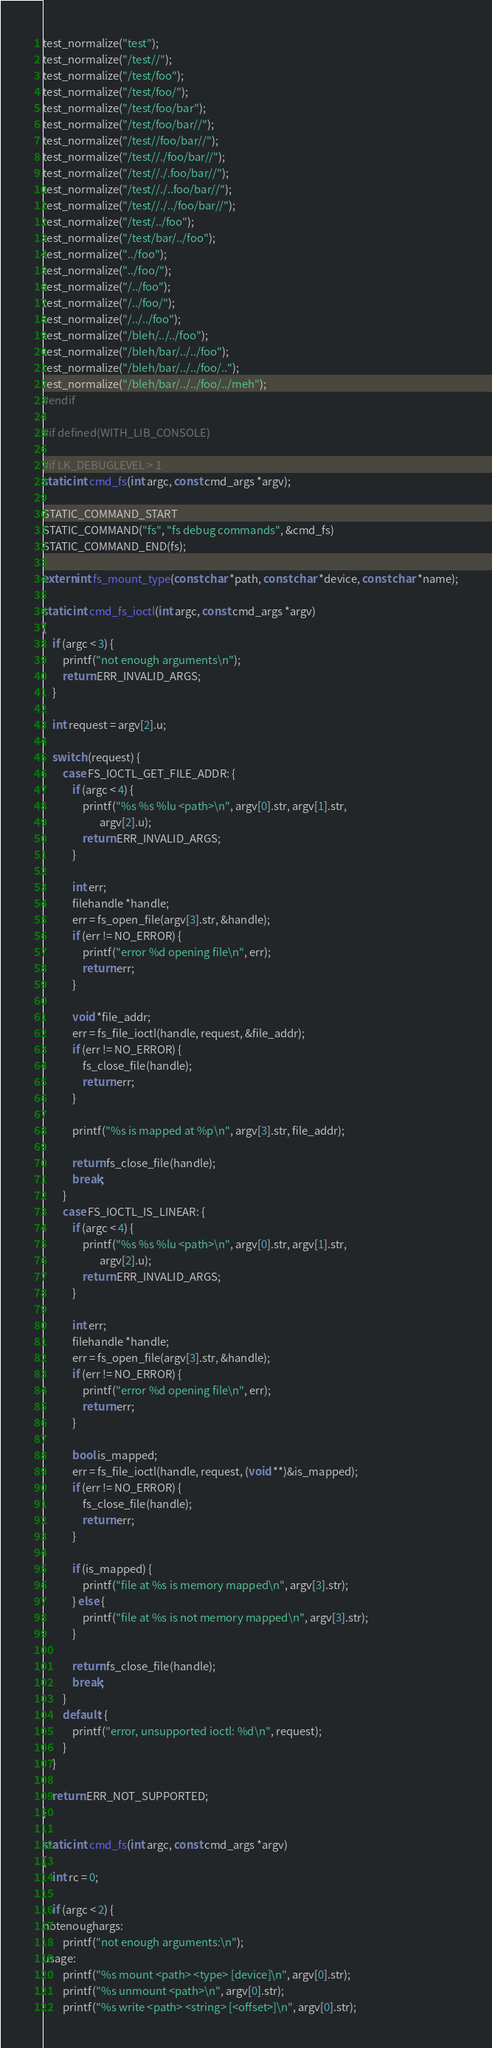<code> <loc_0><loc_0><loc_500><loc_500><_C_>test_normalize("test");
test_normalize("/test//");
test_normalize("/test/foo");
test_normalize("/test/foo/");
test_normalize("/test/foo/bar");
test_normalize("/test/foo/bar//");
test_normalize("/test//foo/bar//");
test_normalize("/test//./foo/bar//");
test_normalize("/test//./.foo/bar//");
test_normalize("/test//./..foo/bar//");
test_normalize("/test//./../foo/bar//");
test_normalize("/test/../foo");
test_normalize("/test/bar/../foo");
test_normalize("../foo");
test_normalize("../foo/");
test_normalize("/../foo");
test_normalize("/../foo/");
test_normalize("/../../foo");
test_normalize("/bleh/../../foo");
test_normalize("/bleh/bar/../../foo");
test_normalize("/bleh/bar/../../foo/..");
test_normalize("/bleh/bar/../../foo/../meh");
#endif

#if defined(WITH_LIB_CONSOLE)

#if LK_DEBUGLEVEL > 1
static int cmd_fs(int argc, const cmd_args *argv);

STATIC_COMMAND_START
STATIC_COMMAND("fs", "fs debug commands", &cmd_fs)
STATIC_COMMAND_END(fs);

extern int fs_mount_type(const char *path, const char *device, const char *name);

static int cmd_fs_ioctl(int argc, const cmd_args *argv)
{
    if (argc < 3) {
        printf("not enough arguments\n");
        return ERR_INVALID_ARGS;
    }

    int request = argv[2].u;

    switch (request) {
        case FS_IOCTL_GET_FILE_ADDR: {
            if (argc < 4) {
                printf("%s %s %lu <path>\n", argv[0].str, argv[1].str,
                       argv[2].u);
                return ERR_INVALID_ARGS;
            }

            int err;
            filehandle *handle;
            err = fs_open_file(argv[3].str, &handle);
            if (err != NO_ERROR) {
                printf("error %d opening file\n", err);
                return err;
            }

            void *file_addr;
            err = fs_file_ioctl(handle, request, &file_addr);
            if (err != NO_ERROR) {
                fs_close_file(handle);
                return err;
            }

            printf("%s is mapped at %p\n", argv[3].str, file_addr);

            return fs_close_file(handle);
            break;
        }
        case FS_IOCTL_IS_LINEAR: {
            if (argc < 4) {
                printf("%s %s %lu <path>\n", argv[0].str, argv[1].str,
                       argv[2].u);
                return ERR_INVALID_ARGS;
            }

            int err;
            filehandle *handle;
            err = fs_open_file(argv[3].str, &handle);
            if (err != NO_ERROR) {
                printf("error %d opening file\n", err);
                return err;
            }

            bool is_mapped;
            err = fs_file_ioctl(handle, request, (void **)&is_mapped);
            if (err != NO_ERROR) {
                fs_close_file(handle);
                return err;
            }

            if (is_mapped) {
                printf("file at %s is memory mapped\n", argv[3].str);
            } else {
                printf("file at %s is not memory mapped\n", argv[3].str);
            }

            return fs_close_file(handle);
            break;
        }
        default: {
            printf("error, unsupported ioctl: %d\n", request);
        }
    }

    return ERR_NOT_SUPPORTED;
}

static int cmd_fs(int argc, const cmd_args *argv)
{
    int rc = 0;

    if (argc < 2) {
notenoughargs:
        printf("not enough arguments:\n");
usage:
        printf("%s mount <path> <type> [device]\n", argv[0].str);
        printf("%s unmount <path>\n", argv[0].str);
        printf("%s write <path> <string> [<offset>]\n", argv[0].str);</code> 